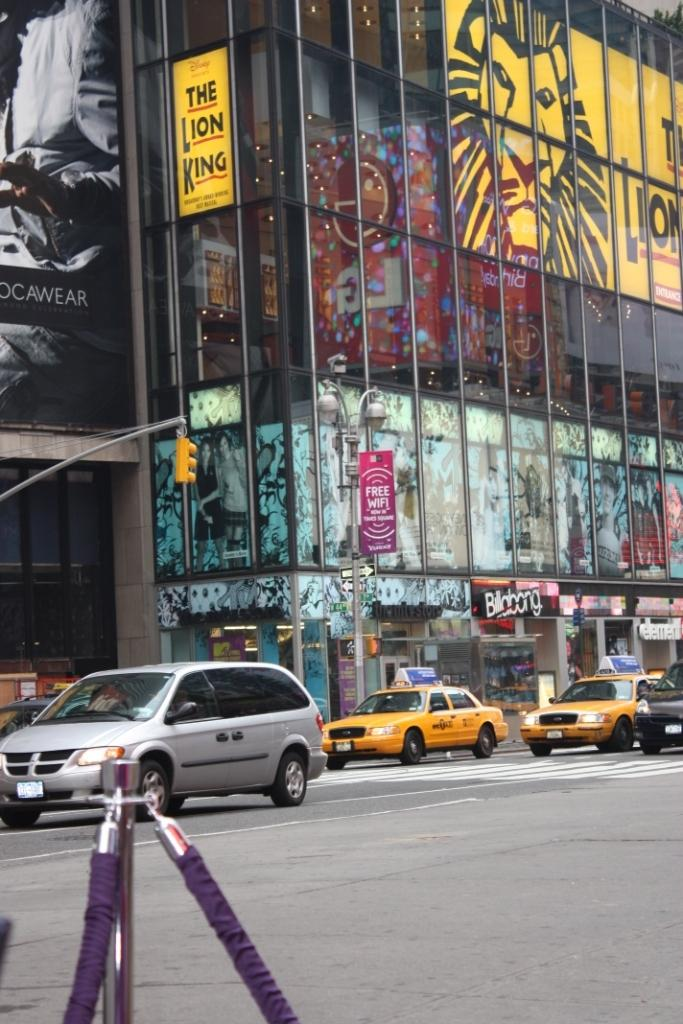<image>
Render a clear and concise summary of the photo. a Billabong ad next to the street outside 